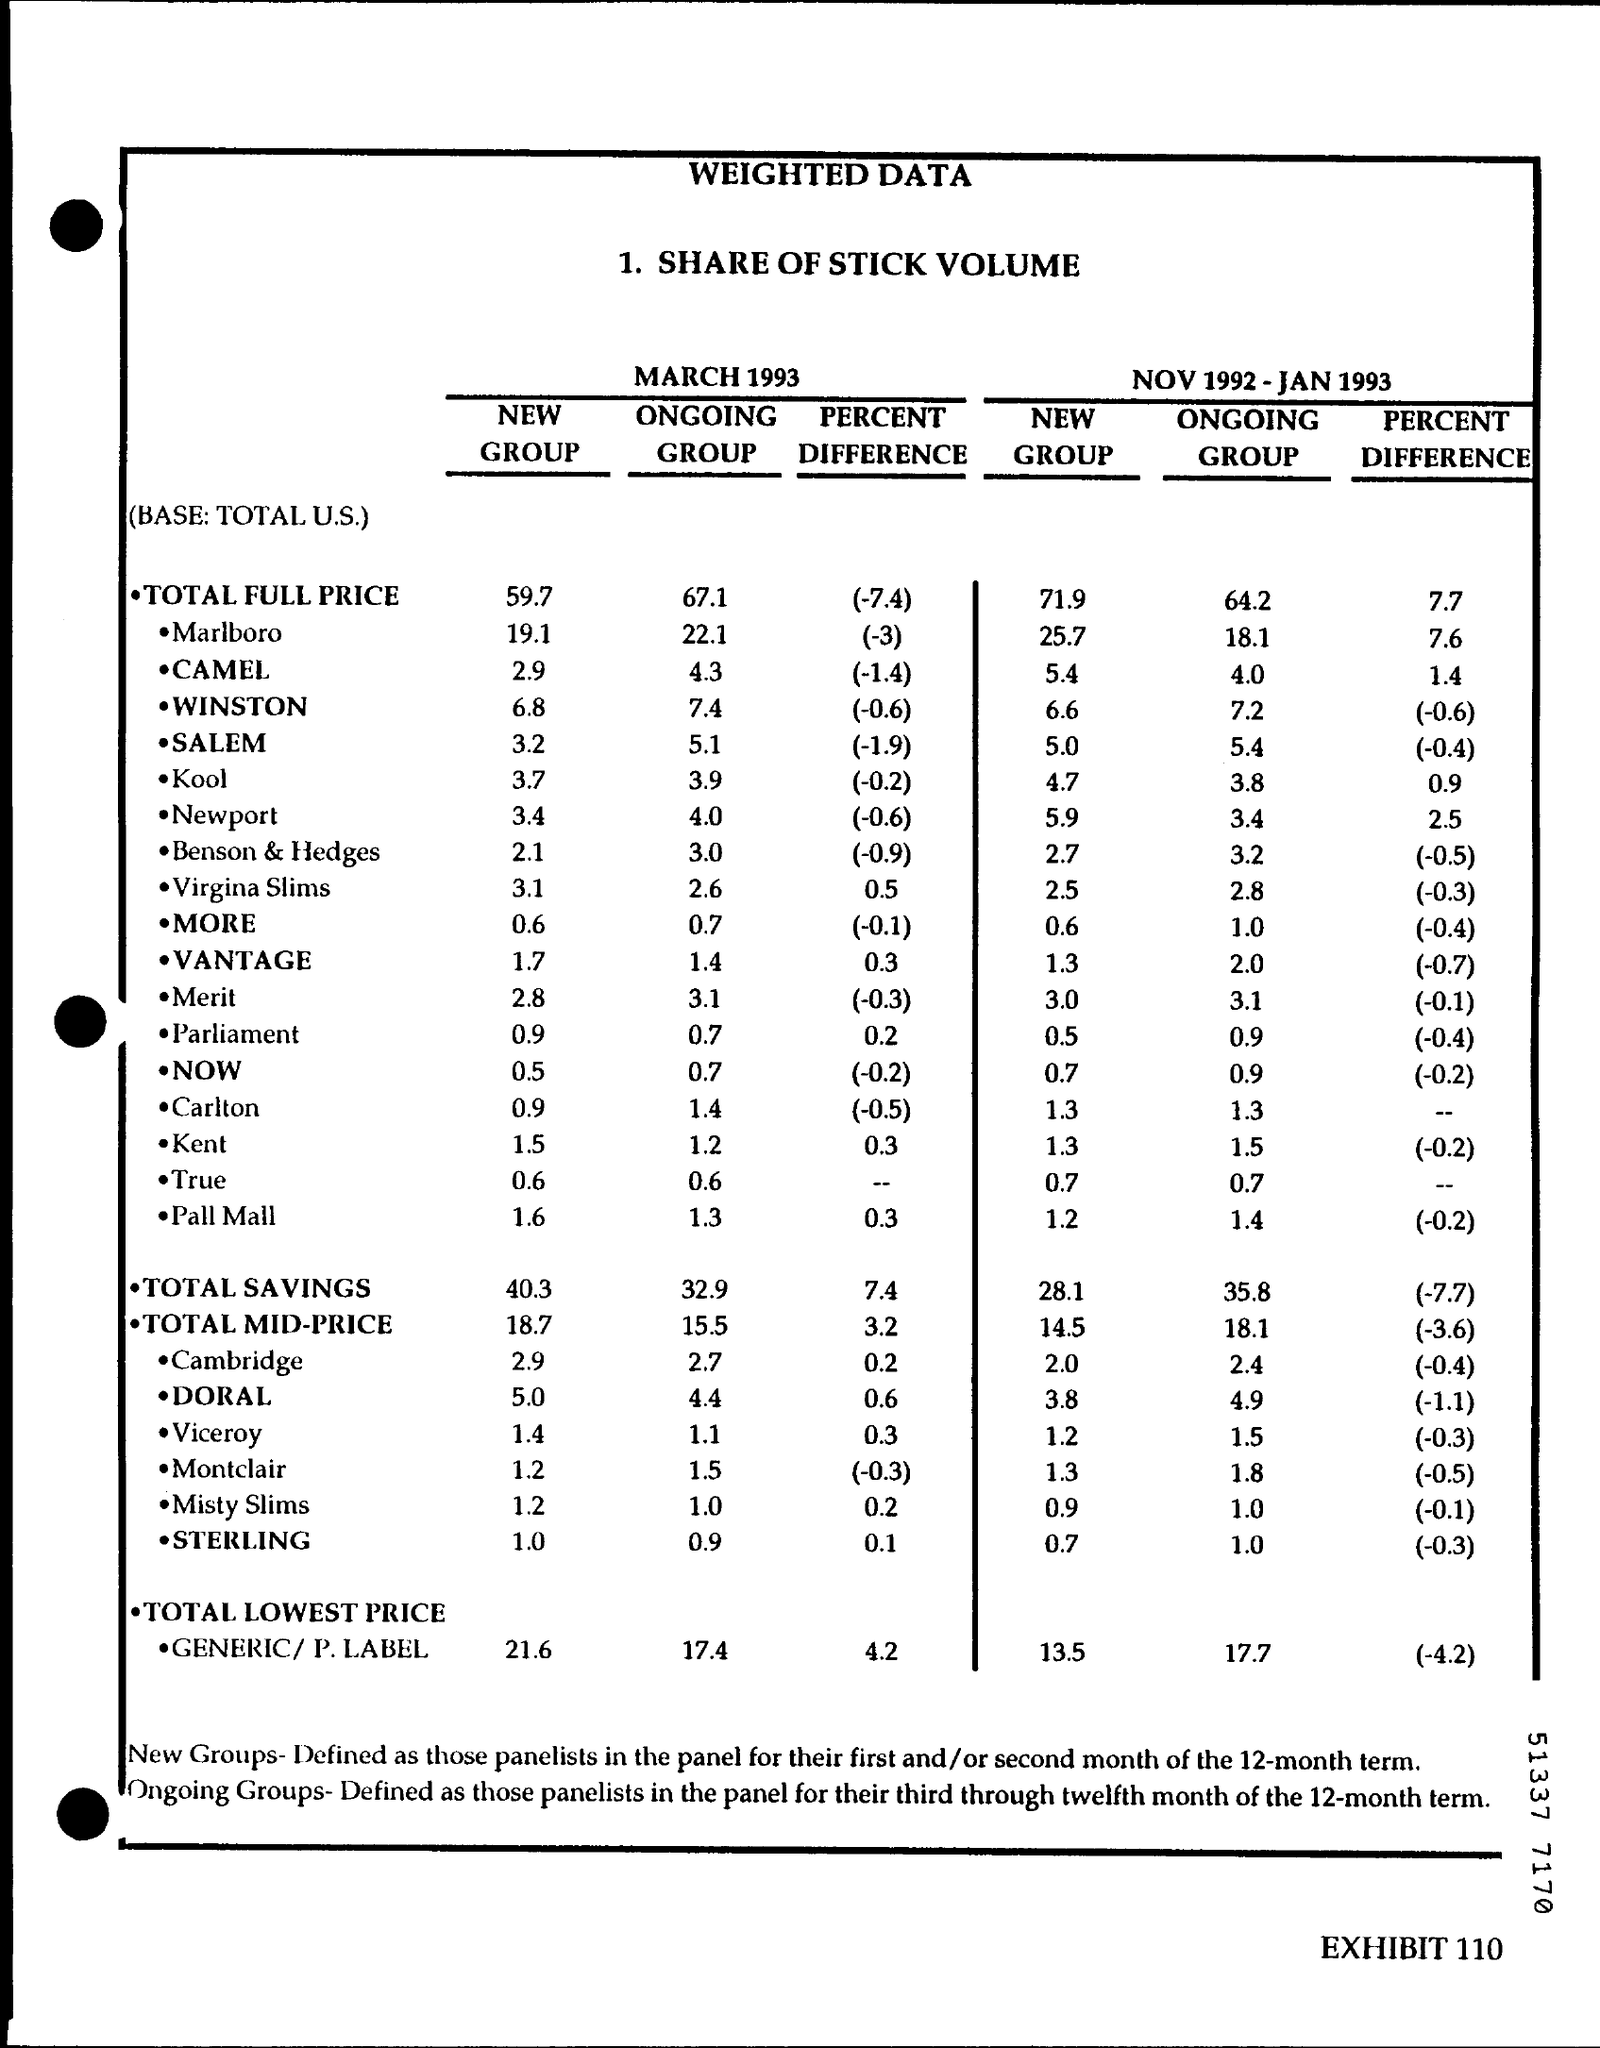Outline some significant characteristics in this image. The title of the document is 'Weighted Data'. The total savings for the ongoing group in March 1993 is 32.9. The total full price percent difference for March 1993 was (-7.4). The total full price for the ongoing group for March 1993 is $67.10. The total savings for the new group from November 1992 to January 1993 was 28.1%. 